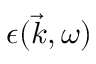Convert formula to latex. <formula><loc_0><loc_0><loc_500><loc_500>\epsilon ( \vec { k } , \omega )</formula> 